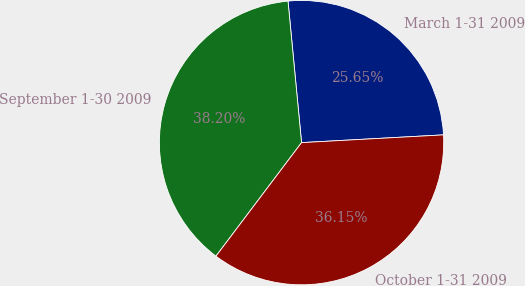Convert chart. <chart><loc_0><loc_0><loc_500><loc_500><pie_chart><fcel>March 1-31 2009<fcel>September 1-30 2009<fcel>October 1-31 2009<nl><fcel>25.65%<fcel>38.2%<fcel>36.15%<nl></chart> 